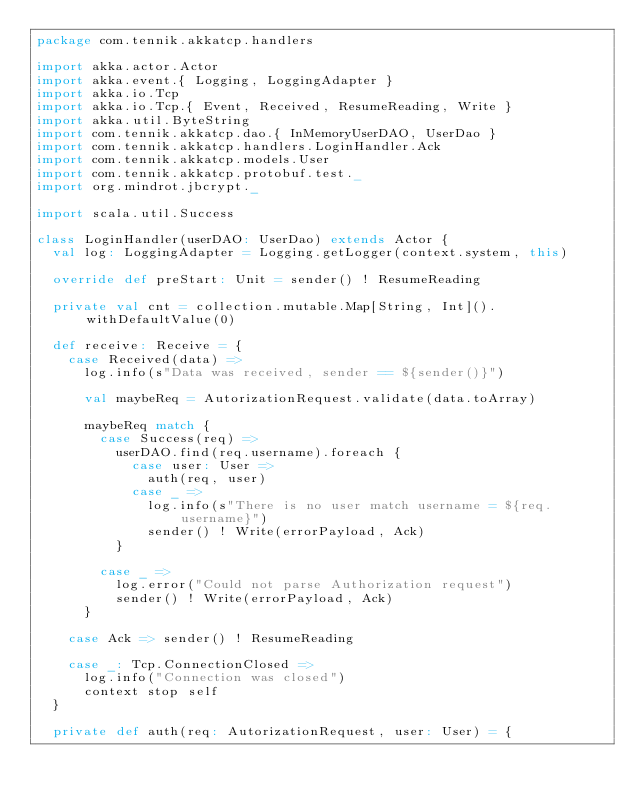<code> <loc_0><loc_0><loc_500><loc_500><_Scala_>package com.tennik.akkatcp.handlers

import akka.actor.Actor
import akka.event.{ Logging, LoggingAdapter }
import akka.io.Tcp
import akka.io.Tcp.{ Event, Received, ResumeReading, Write }
import akka.util.ByteString
import com.tennik.akkatcp.dao.{ InMemoryUserDAO, UserDao }
import com.tennik.akkatcp.handlers.LoginHandler.Ack
import com.tennik.akkatcp.models.User
import com.tennik.akkatcp.protobuf.test._
import org.mindrot.jbcrypt._

import scala.util.Success

class LoginHandler(userDAO: UserDao) extends Actor {
  val log: LoggingAdapter = Logging.getLogger(context.system, this)

  override def preStart: Unit = sender() ! ResumeReading

  private val cnt = collection.mutable.Map[String, Int]().withDefaultValue(0)

  def receive: Receive = {
    case Received(data) =>
      log.info(s"Data was received, sender == ${sender()}")

      val maybeReq = AutorizationRequest.validate(data.toArray)

      maybeReq match {
        case Success(req) =>
          userDAO.find(req.username).foreach {
            case user: User =>
              auth(req, user)
            case _ =>
              log.info(s"There is no user match username = ${req.username}")
              sender() ! Write(errorPayload, Ack)
          }

        case _ =>
          log.error("Could not parse Authorization request")
          sender() ! Write(errorPayload, Ack)
      }

    case Ack => sender() ! ResumeReading

    case _: Tcp.ConnectionClosed =>
      log.info("Connection was closed")
      context stop self
  }

  private def auth(req: AutorizationRequest, user: User) = {</code> 